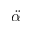Convert formula to latex. <formula><loc_0><loc_0><loc_500><loc_500>\ddot { \alpha }</formula> 